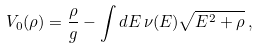Convert formula to latex. <formula><loc_0><loc_0><loc_500><loc_500>V _ { 0 } ( \rho ) = \frac { \rho } { g } - \int d E \, \nu ( E ) \sqrt { E ^ { 2 } + \rho } \, ,</formula> 